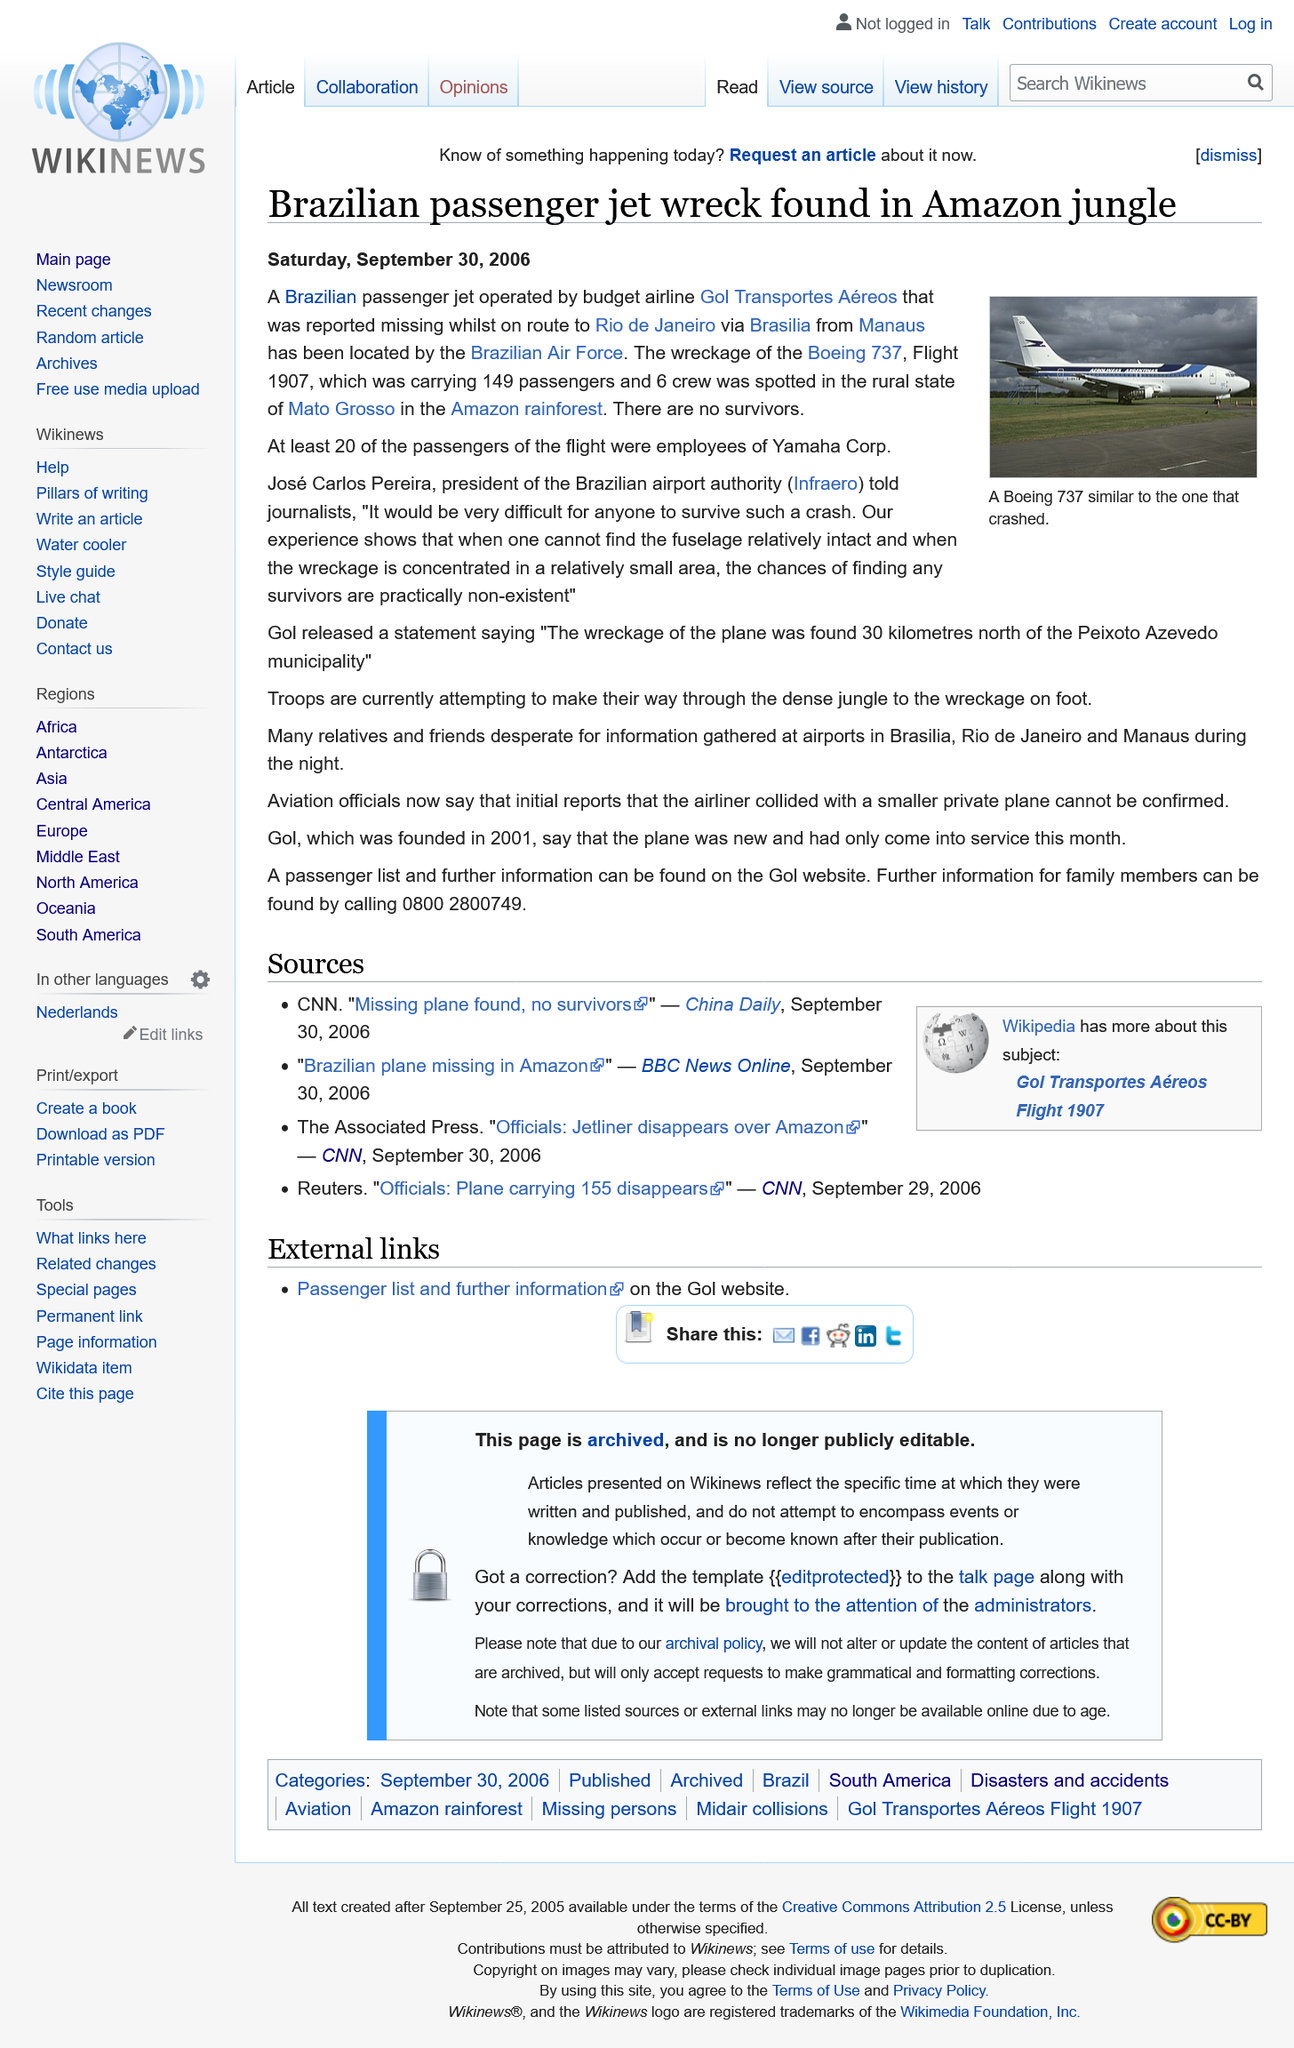List a handful of essential elements in this visual. At least 20 passengers on the jet were employees of Yamaha Corp. A Brazilian passenger jet was found wrecked in the Amazon jungle. On June 3rd, 2021, the Brazilian Air Force located the wreckage of a passenger jet in the Amazon jungle. The wreckage of the Brazilian passenger jet was found by the Brazilian Air Force in the Amazon jungle on June 3rd, 2021. 